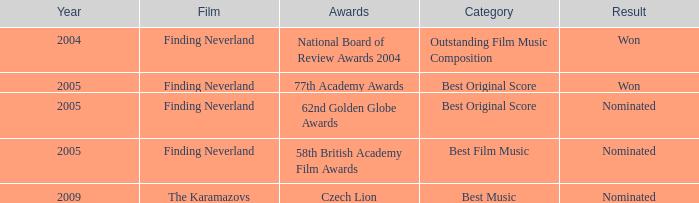How many years were there for the 62nd golden globe awards? 2005.0. 